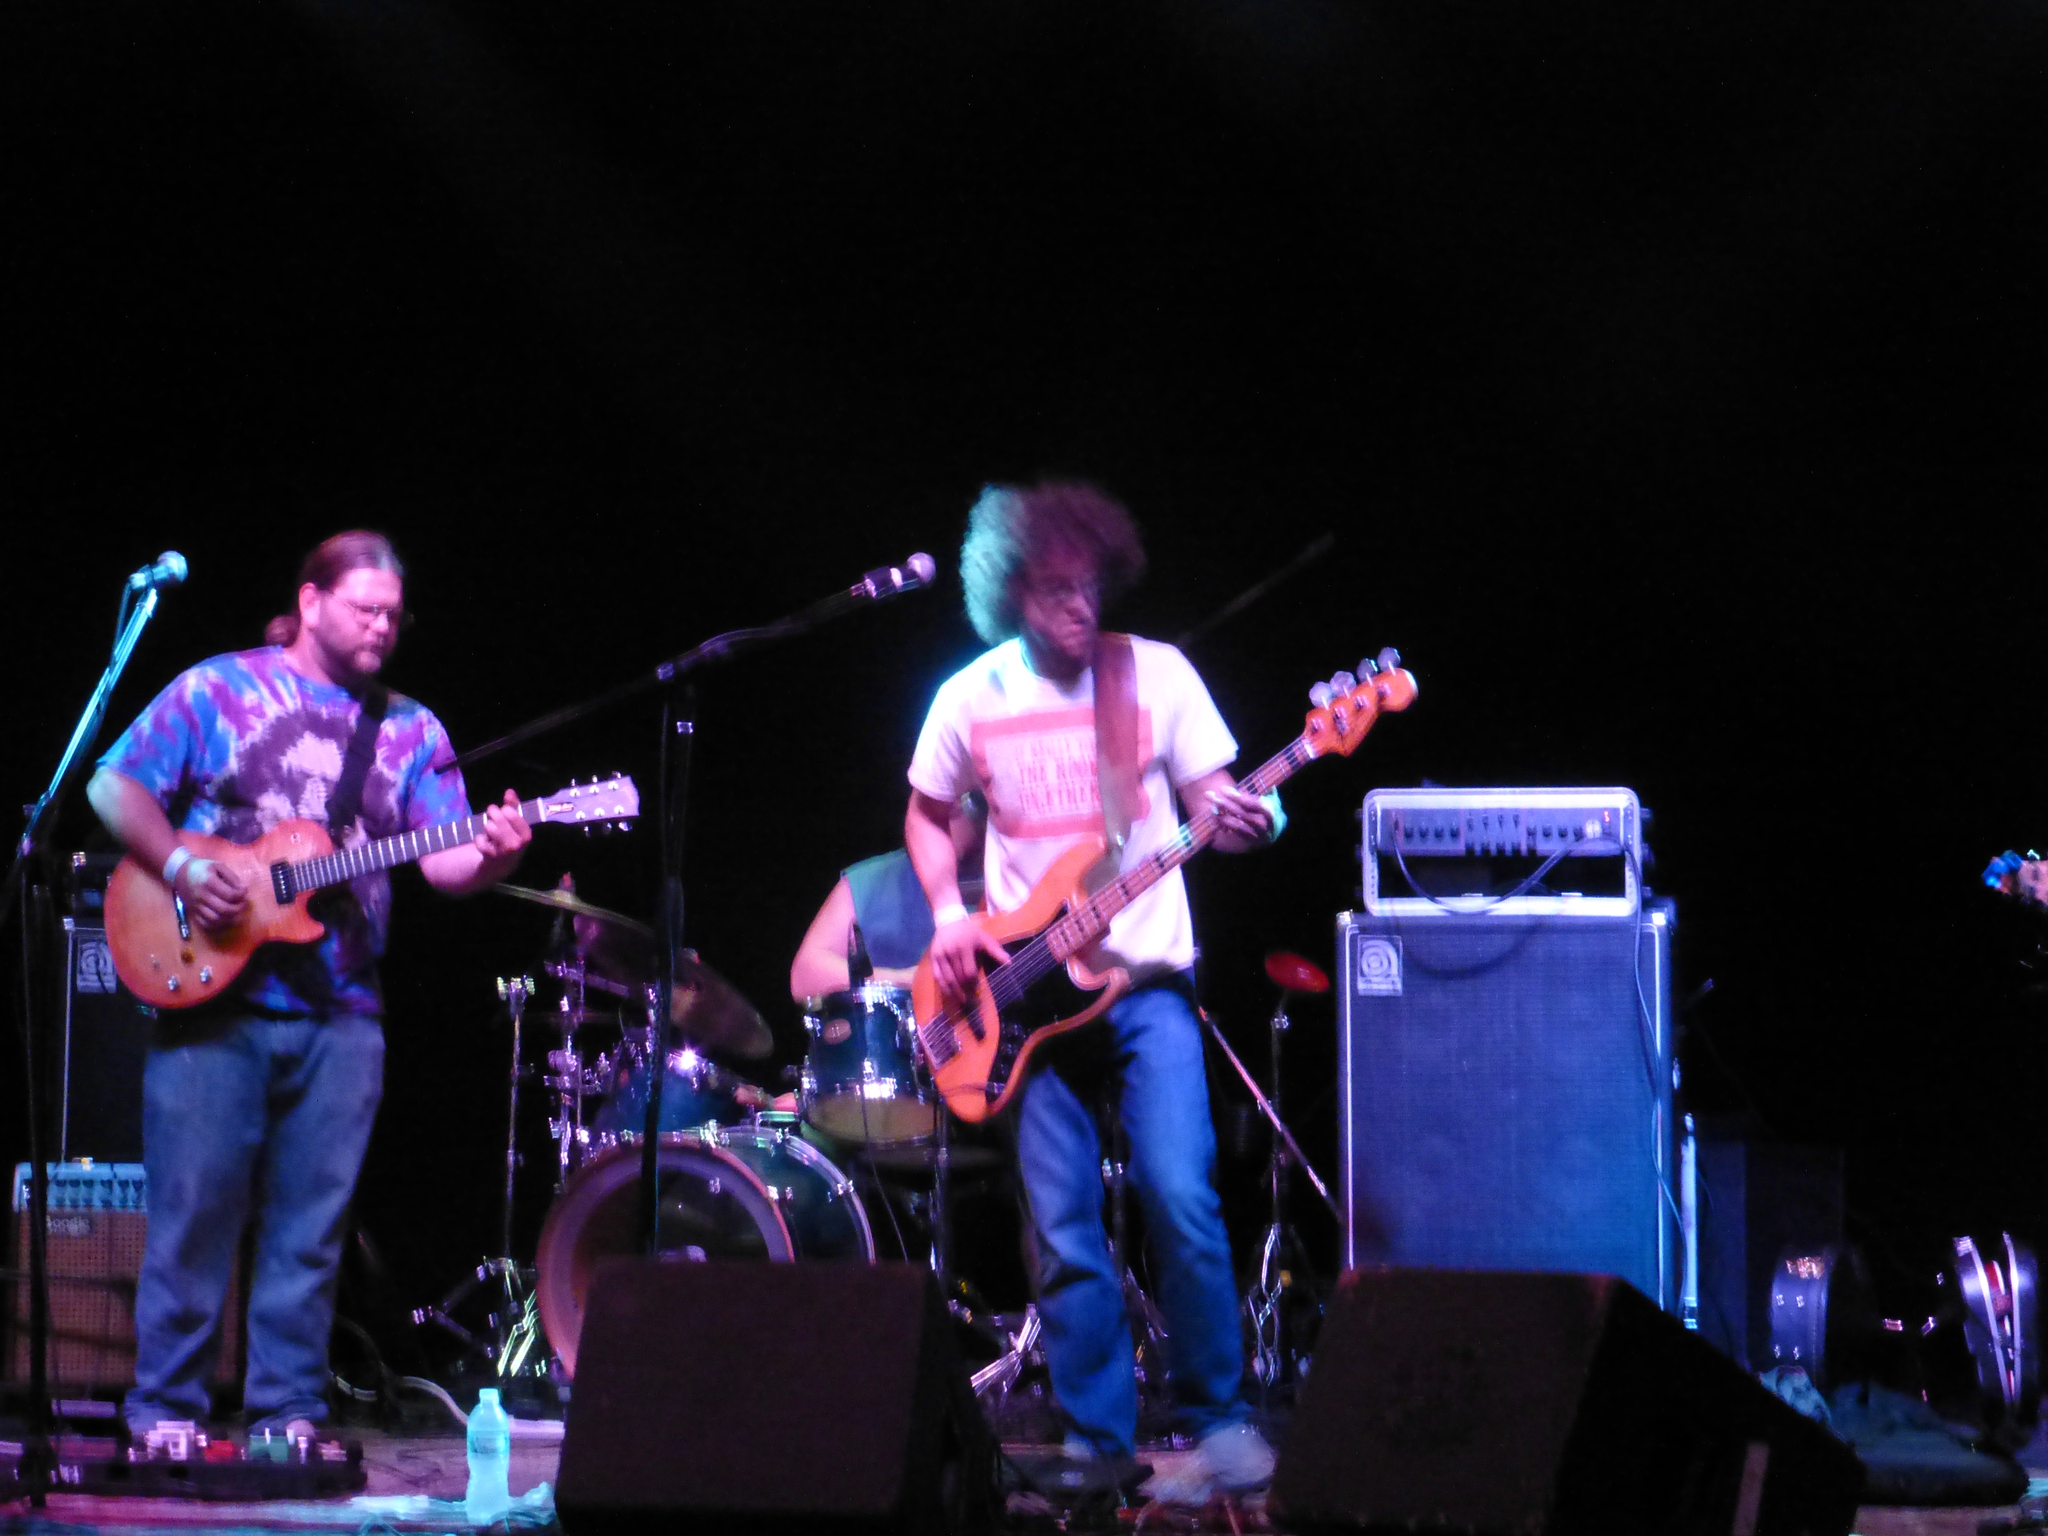Please provide a concise description of this image. As we can see in the image there are three persons, musical drums, mics, guitars and a bottle. The image is little dark. The two persons, one on the left and other on the right are playing musical drums. The person in the middle is playing musical drums. 